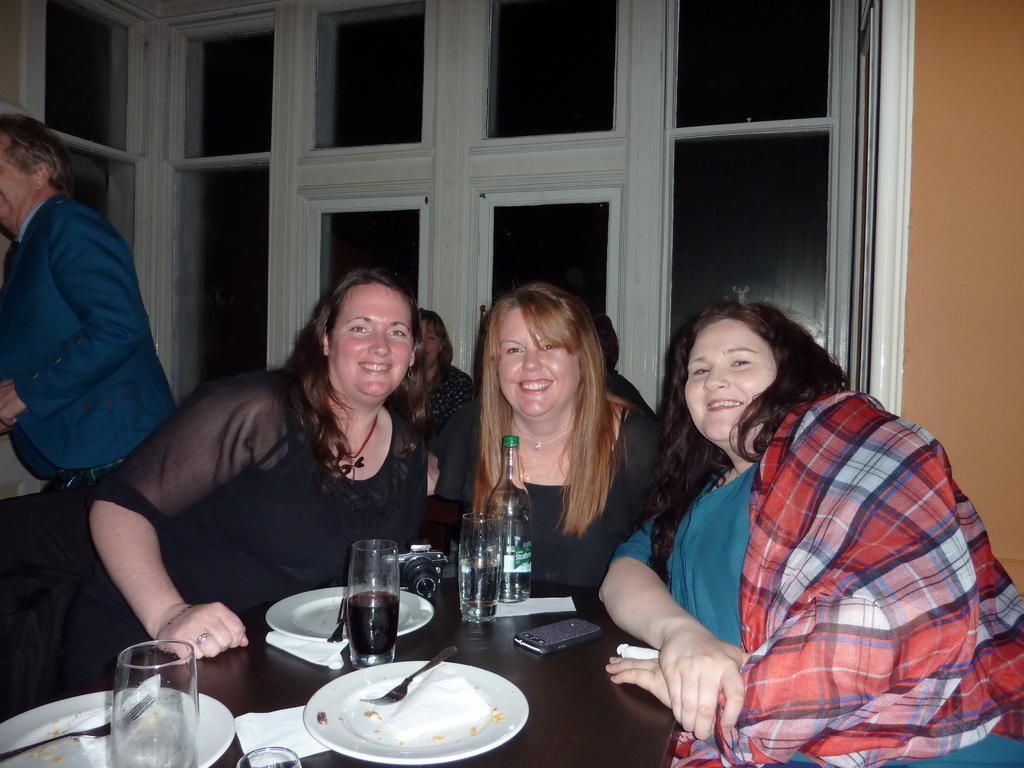Please provide a concise description of this image. In this picture we can see some people sitting in front of a table, three is a bottle, three glasses, a camera, three plates, a mobile phone present on the table, we can see forks in these plates, we can see tissue papers here, in the background we can see windows. 